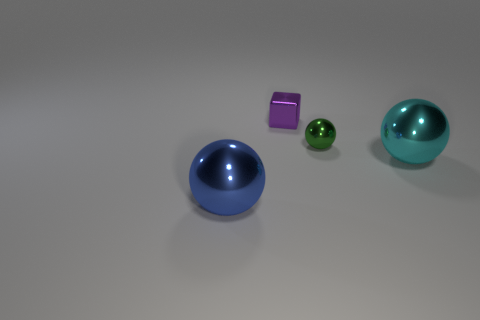The big object left of the big thing to the right of the small purple object is what shape? The object in question is a sphere. To be more precise, it's the large blue object positioned to the left of the teal spherical object, which is itself to the right of the small purple cube. The blue object's spherical shape is characterized by its smooth, curved surface and lack of edges or vertices. 